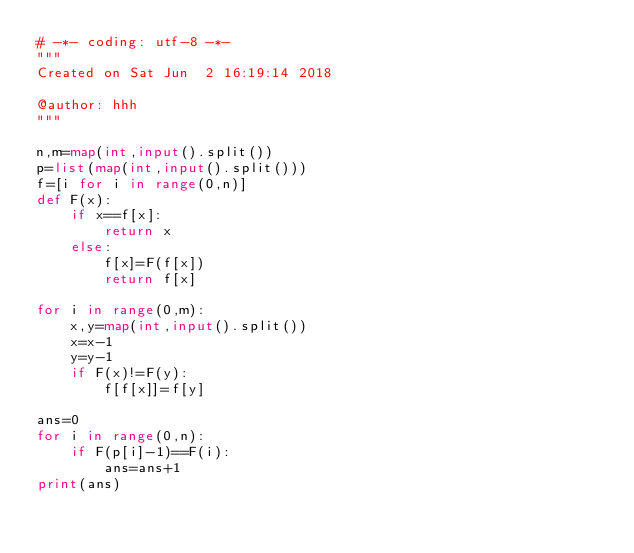<code> <loc_0><loc_0><loc_500><loc_500><_Python_># -*- coding: utf-8 -*-
"""
Created on Sat Jun  2 16:19:14 2018

@author: hhh
"""

n,m=map(int,input().split())
p=list(map(int,input().split()))
f=[i for i in range(0,n)]
def F(x):
    if x==f[x]:
        return x
    else:
        f[x]=F(f[x])
        return f[x]
    
for i in range(0,m):
    x,y=map(int,input().split())
    x=x-1
    y=y-1
    if F(x)!=F(y):
        f[f[x]]=f[y]

ans=0
for i in range(0,n):
    if F(p[i]-1)==F(i):
        ans=ans+1
print(ans)</code> 